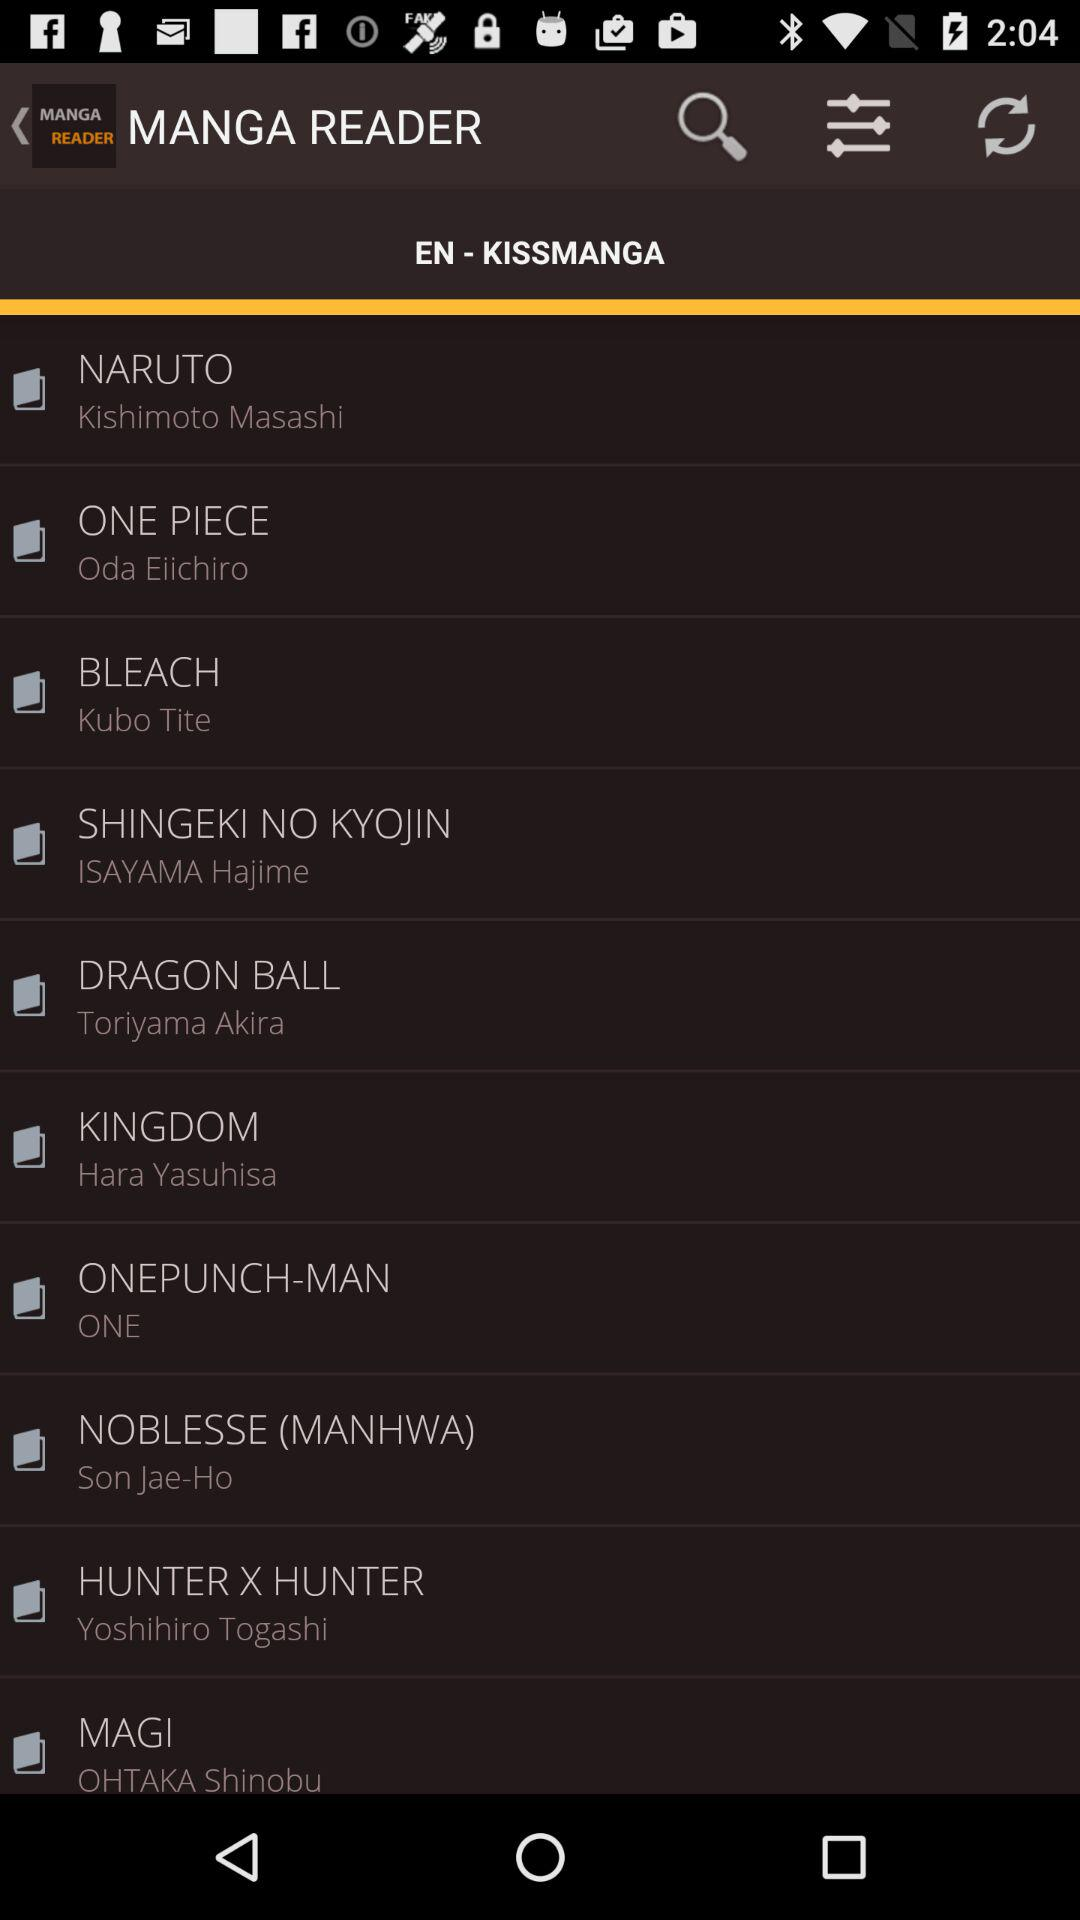Who is the author of the book "BLEACH"? The author is Kubo Tite. 